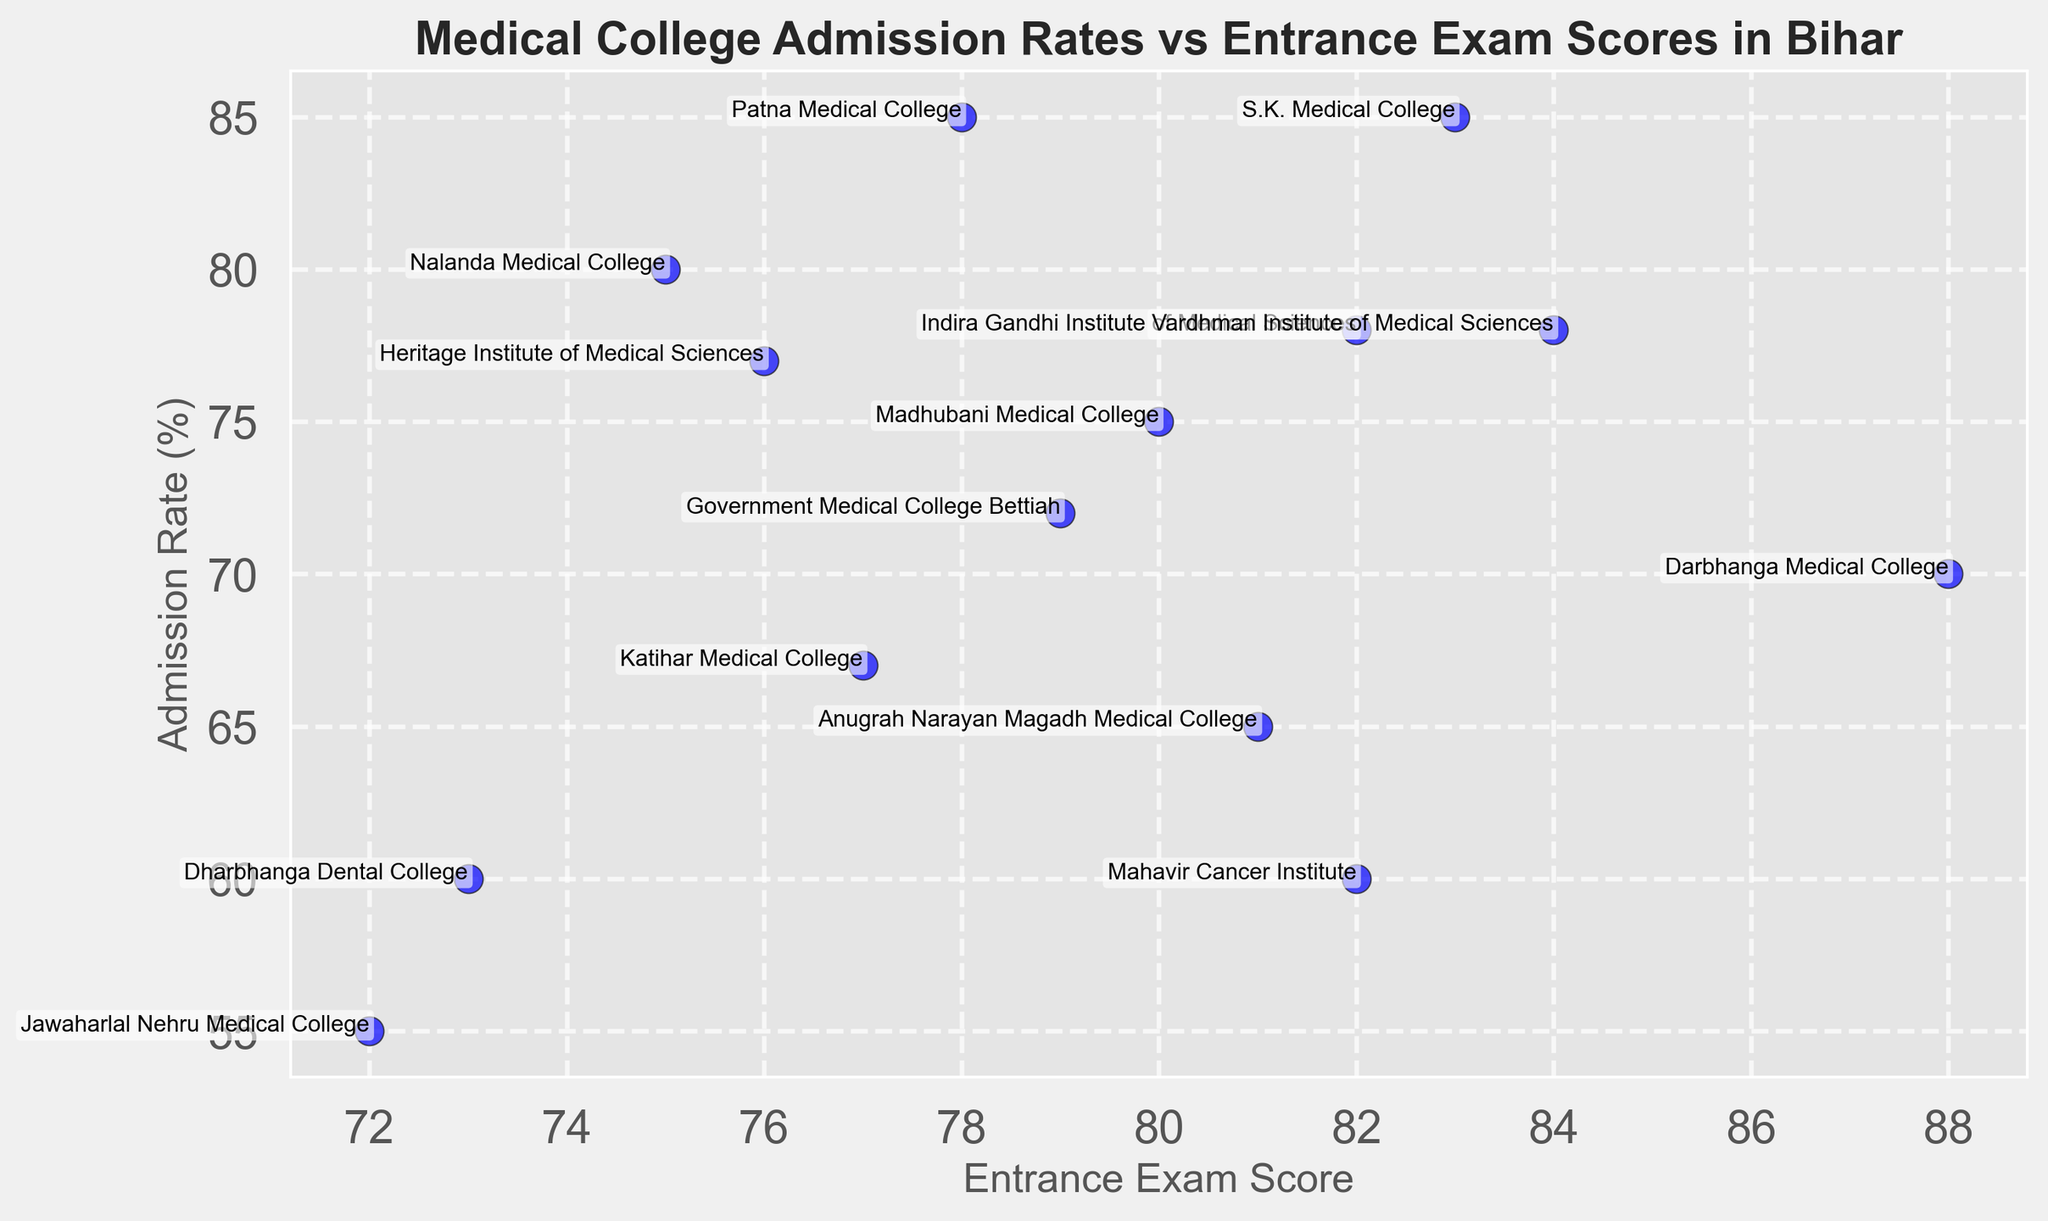What is the admission rate for the Jawaharlal Nehru Medical College? The college names and their respective admission rates are annotated on the scatter plot. Find "Jawaharlal Nehru Medical College" and read off the corresponding admission rate.
Answer: 55% Which college has the highest admission rate, and what is its entrance exam score? Identify the point with the highest admission rate on the vertical axis and check its corresponding entrance exam score.
Answer: Patna Medical College, 78 How does the admission rate of Darbhanga Medical College compare to that of Anugrah Narayan Magadh Medical College? Locate both colleges on the scatter plot. Observe and compare their positions on the vertical axis, which represents the admission rate.
Answer: Higher Which college has an entrance exam score of 84, and what is its admission rate? Identify the point corresponding to an entrance exam score of 84 on the horizontal axis and check the associated college name and admission rate.
Answer: Vardhman Institute of Medical Sciences, 78% If we consider colleges with entrance exam scores above 80, which one has the lowest admission rate and what is it? Filter points with entrance exam scores above 80, then identify the one with the lowest position on the vertical axis measuring admission rates.
Answer: Anugrah Narayan Magadh Medical College, 65% What is the average admission rate of all colleges? Extract the admission rates for all colleges, sum them up, and divide by the number of colleges. (85 + 78 + 80 + 70 + 65 + 55 + 60 + 67 + 75 + 78 + 72 + 85 + 77 + 60) / 14
Answer: 72.14% Which medical college has both an admission rate above 80% and an entrance exam score above 80? Examine the points that are both above 80 on the vertical axis (admission rates) and horizontal axis (entrance exam scores). Identify the college name annotated at such points.
Answer: S.K. Medical College What is the difference in entrance exam scores between the college with the highest admission rate and the one with the lowest admission rate? Find the entrance exam score for the highest admission rate college (Patna Medical College) and the lowest admission rate college (Jawaharlal Nehru Medical College), then subtract the two values.
Answer: 78 - 72 = 6 If a college has an entrance exam score of 82, which colleges have an admission rate greater than or equal to its admission rate? Identify the colleges with entrance exam scores of 82 and note their admission rates. Then find colleges with admission rates greater than or equal to this rate.
Answer: Indira Gandhi Institute of Medical Sciences, Mahavir Cancer Institute 